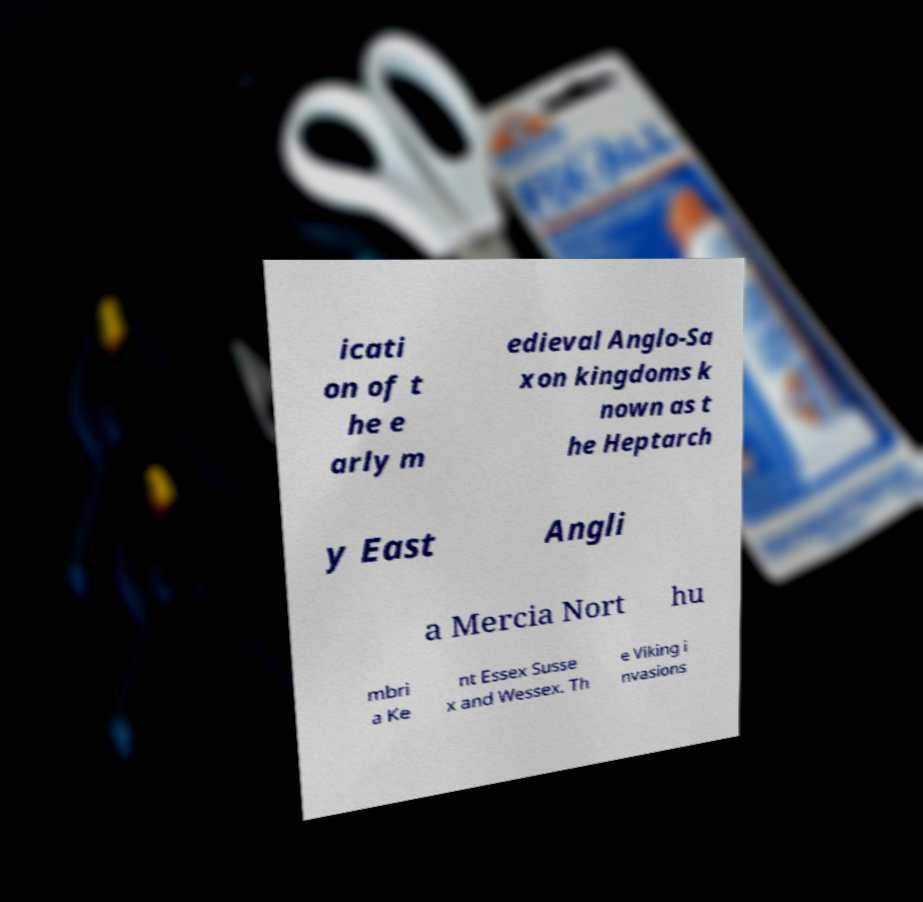What messages or text are displayed in this image? I need them in a readable, typed format. icati on of t he e arly m edieval Anglo-Sa xon kingdoms k nown as t he Heptarch y East Angli a Mercia Nort hu mbri a Ke nt Essex Susse x and Wessex. Th e Viking i nvasions 